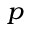<formula> <loc_0><loc_0><loc_500><loc_500>^ { p }</formula> 